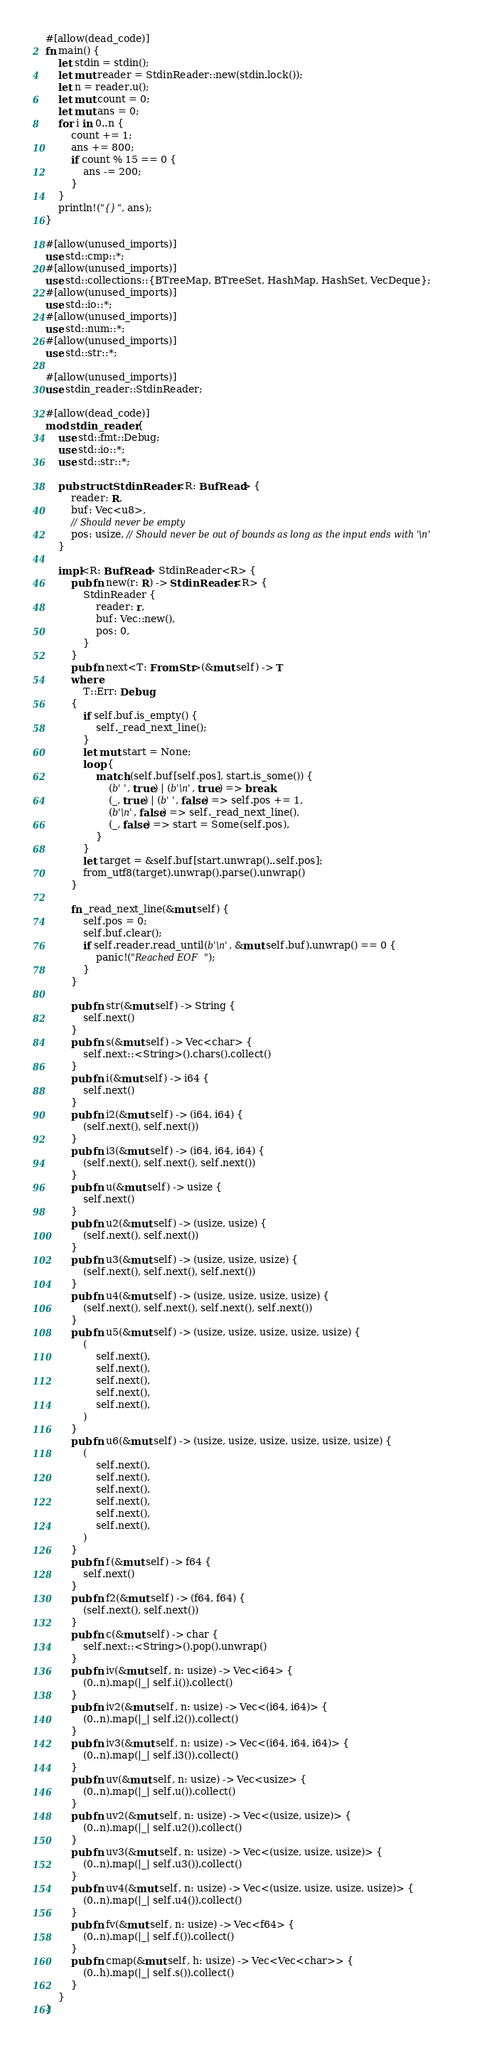Convert code to text. <code><loc_0><loc_0><loc_500><loc_500><_Rust_>#[allow(dead_code)]
fn main() {
    let stdin = stdin();
    let mut reader = StdinReader::new(stdin.lock());
    let n = reader.u();
    let mut count = 0;
    let mut ans = 0;
    for i in 0..n {
        count += 1;
        ans += 800;
        if count % 15 == 0 {
            ans -= 200;
        }
    }
    println!("{}", ans);
}

#[allow(unused_imports)]
use std::cmp::*;
#[allow(unused_imports)]
use std::collections::{BTreeMap, BTreeSet, HashMap, HashSet, VecDeque};
#[allow(unused_imports)]
use std::io::*;
#[allow(unused_imports)]
use std::num::*;
#[allow(unused_imports)]
use std::str::*;

#[allow(unused_imports)]
use stdin_reader::StdinReader;

#[allow(dead_code)]
mod stdin_reader {
    use std::fmt::Debug;
    use std::io::*;
    use std::str::*;

    pub struct StdinReader<R: BufRead> {
        reader: R,
        buf: Vec<u8>,
        // Should never be empty
        pos: usize, // Should never be out of bounds as long as the input ends with '\n'
    }

    impl<R: BufRead> StdinReader<R> {
        pub fn new(r: R) -> StdinReader<R> {
            StdinReader {
                reader: r,
                buf: Vec::new(),
                pos: 0,
            }
        }
        pub fn next<T: FromStr>(&mut self) -> T
        where
            T::Err: Debug,
        {
            if self.buf.is_empty() {
                self._read_next_line();
            }
            let mut start = None;
            loop {
                match (self.buf[self.pos], start.is_some()) {
                    (b' ', true) | (b'\n', true) => break,
                    (_, true) | (b' ', false) => self.pos += 1,
                    (b'\n', false) => self._read_next_line(),
                    (_, false) => start = Some(self.pos),
                }
            }
            let target = &self.buf[start.unwrap()..self.pos];
            from_utf8(target).unwrap().parse().unwrap()
        }

        fn _read_next_line(&mut self) {
            self.pos = 0;
            self.buf.clear();
            if self.reader.read_until(b'\n', &mut self.buf).unwrap() == 0 {
                panic!("Reached EOF");
            }
        }

        pub fn str(&mut self) -> String {
            self.next()
        }
        pub fn s(&mut self) -> Vec<char> {
            self.next::<String>().chars().collect()
        }
        pub fn i(&mut self) -> i64 {
            self.next()
        }
        pub fn i2(&mut self) -> (i64, i64) {
            (self.next(), self.next())
        }
        pub fn i3(&mut self) -> (i64, i64, i64) {
            (self.next(), self.next(), self.next())
        }
        pub fn u(&mut self) -> usize {
            self.next()
        }
        pub fn u2(&mut self) -> (usize, usize) {
            (self.next(), self.next())
        }
        pub fn u3(&mut self) -> (usize, usize, usize) {
            (self.next(), self.next(), self.next())
        }
        pub fn u4(&mut self) -> (usize, usize, usize, usize) {
            (self.next(), self.next(), self.next(), self.next())
        }
        pub fn u5(&mut self) -> (usize, usize, usize, usize, usize) {
            (
                self.next(),
                self.next(),
                self.next(),
                self.next(),
                self.next(),
            )
        }
        pub fn u6(&mut self) -> (usize, usize, usize, usize, usize, usize) {
            (
                self.next(),
                self.next(),
                self.next(),
                self.next(),
                self.next(),
                self.next(),
            )
        }
        pub fn f(&mut self) -> f64 {
            self.next()
        }
        pub fn f2(&mut self) -> (f64, f64) {
            (self.next(), self.next())
        }
        pub fn c(&mut self) -> char {
            self.next::<String>().pop().unwrap()
        }
        pub fn iv(&mut self, n: usize) -> Vec<i64> {
            (0..n).map(|_| self.i()).collect()
        }
        pub fn iv2(&mut self, n: usize) -> Vec<(i64, i64)> {
            (0..n).map(|_| self.i2()).collect()
        }
        pub fn iv3(&mut self, n: usize) -> Vec<(i64, i64, i64)> {
            (0..n).map(|_| self.i3()).collect()
        }
        pub fn uv(&mut self, n: usize) -> Vec<usize> {
            (0..n).map(|_| self.u()).collect()
        }
        pub fn uv2(&mut self, n: usize) -> Vec<(usize, usize)> {
            (0..n).map(|_| self.u2()).collect()
        }
        pub fn uv3(&mut self, n: usize) -> Vec<(usize, usize, usize)> {
            (0..n).map(|_| self.u3()).collect()
        }
        pub fn uv4(&mut self, n: usize) -> Vec<(usize, usize, usize, usize)> {
            (0..n).map(|_| self.u4()).collect()
        }
        pub fn fv(&mut self, n: usize) -> Vec<f64> {
            (0..n).map(|_| self.f()).collect()
        }
        pub fn cmap(&mut self, h: usize) -> Vec<Vec<char>> {
            (0..h).map(|_| self.s()).collect()
        }
    }
}
</code> 